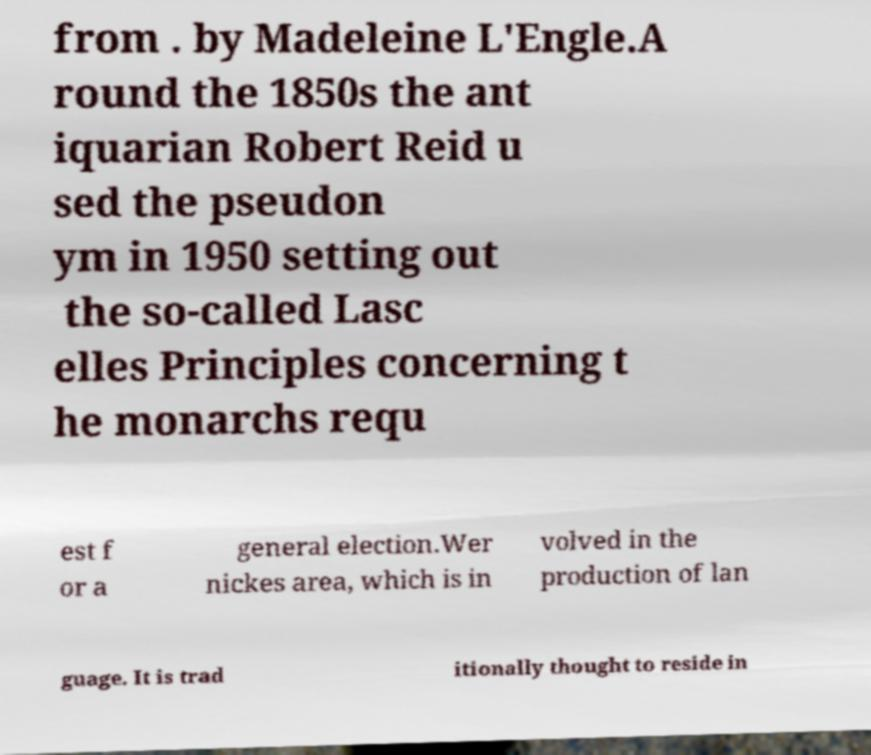Can you accurately transcribe the text from the provided image for me? from . by Madeleine L'Engle.A round the 1850s the ant iquarian Robert Reid u sed the pseudon ym in 1950 setting out the so-called Lasc elles Principles concerning t he monarchs requ est f or a general election.Wer nickes area, which is in volved in the production of lan guage. It is trad itionally thought to reside in 